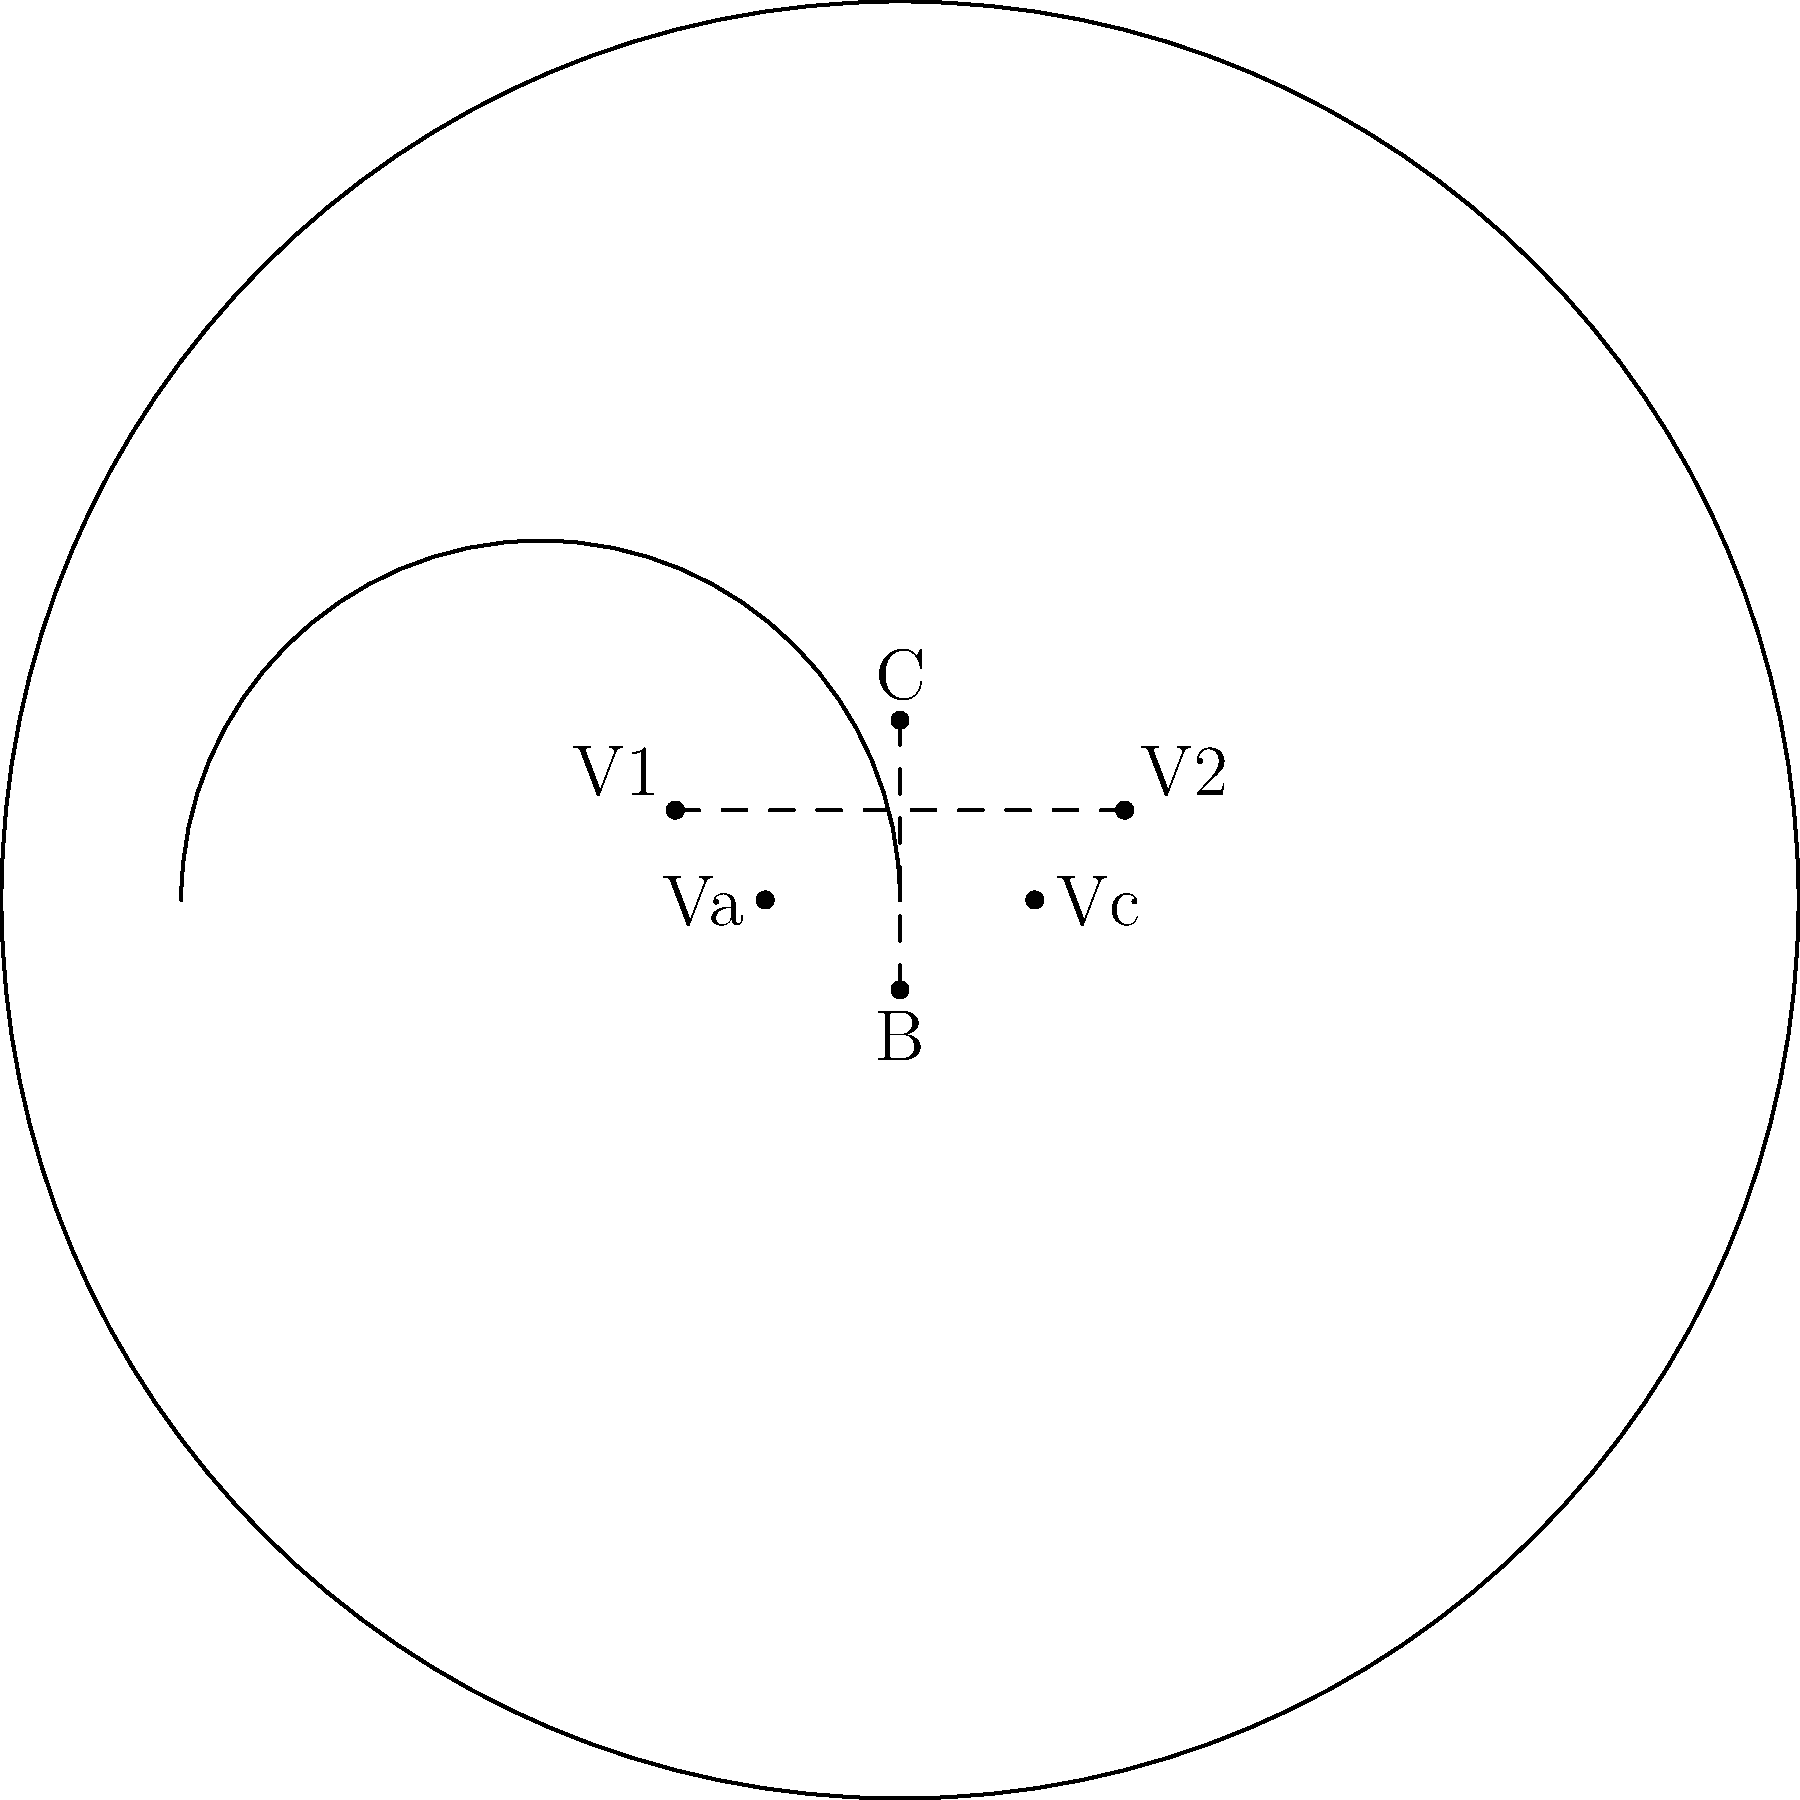In the concert hall diagram, compare the distance between the conductor (C) and the bass (B) to the distance between the first violins (V1) and second violins (V2). Which is greater, and by approximately what factor? To solve this problem, we need to compare the two distances visually:

1. Distance between conductor (C) and bass (B):
   This line spans from the top-center to the bottom-center of the stage area.

2. Distance between first violins (V1) and second violins (V2):
   This line spans horizontally across the front of the stage.

3. Visual comparison:
   The C-B line appears to be noticeably longer than the V1-V2 line.

4. Estimating the factor:
   The C-B line seems to be about 1.5 times the length of the V1-V2 line.

5. Considering the perspective:
   As a pianist familiar with studio recordings, you might be aware that the actual distances in a concert hall can be slightly different from what they appear in a 2D diagram due to the curved nature of the stage and the perspective of the audience.

6. Final estimation:
   Taking into account potential perspective distortions, we can conservatively estimate that the C-B distance is approximately 1.4 to 1.6 times greater than the V1-V2 distance.
Answer: C-B distance, ~1.5 times V1-V2 distance 